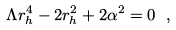<formula> <loc_0><loc_0><loc_500><loc_500>\Lambda r _ { h } ^ { 4 } - 2 r _ { h } ^ { 2 } + 2 \alpha ^ { 2 } = 0 \ ,</formula> 